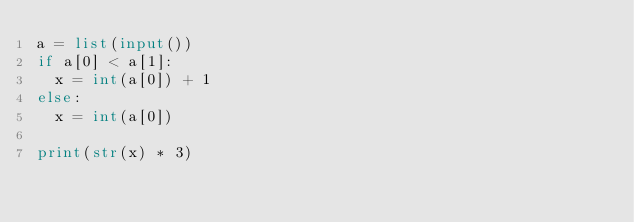Convert code to text. <code><loc_0><loc_0><loc_500><loc_500><_Python_>a = list(input())
if a[0] < a[1]:
  x = int(a[0]) + 1
else:
  x = int(a[0])

print(str(x) * 3)
</code> 